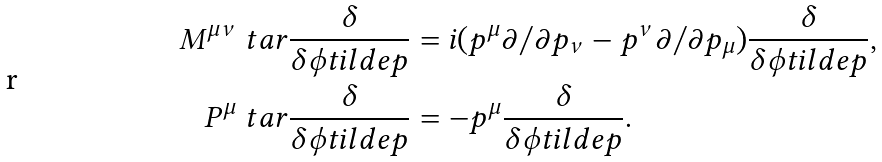<formula> <loc_0><loc_0><loc_500><loc_500>M ^ { \mu \nu } \ t a r \frac { \delta } { \delta \phi t i l d e { p } } & = i ( p ^ { \mu } \partial / \partial p _ { \nu } - p ^ { \nu } \partial / \partial p _ { \mu } ) \frac { \delta } { \delta \phi t i l d e { p } } , \\ P ^ { \mu } \ t a r \frac { \delta } { \delta \phi t i l d e { p } } & = - p ^ { \mu } \frac { \delta } { \delta \phi t i l d e { p } } .</formula> 